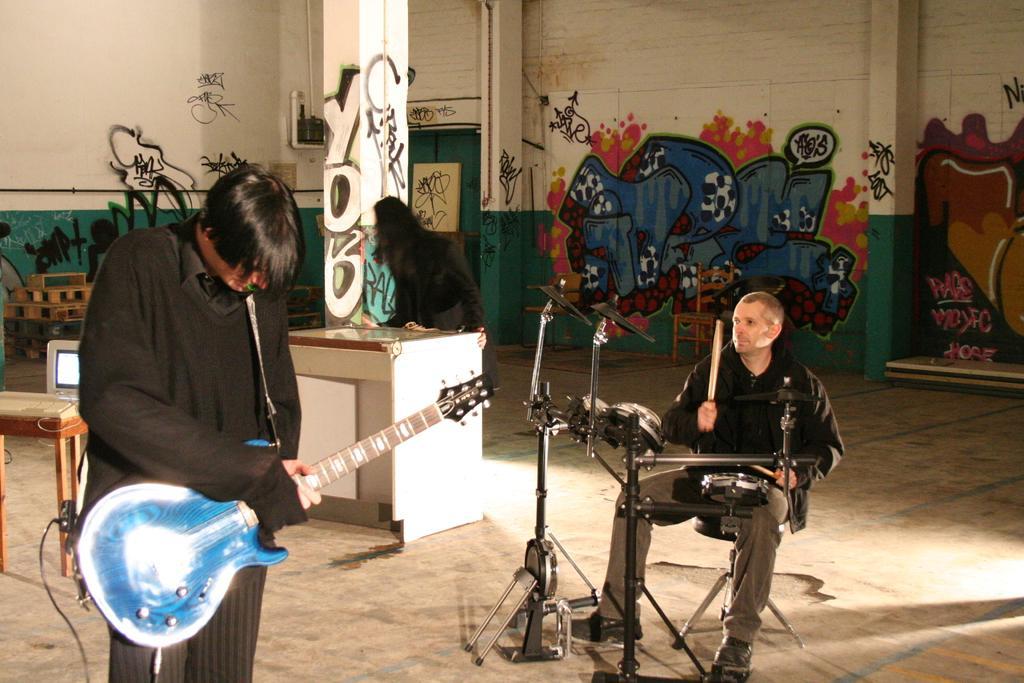Could you give a brief overview of what you see in this image? In this image we can see persons holding musical instruments, woman standing on the floor, a desktop on the side table, pipelines to the walls and walls with graffiti. 